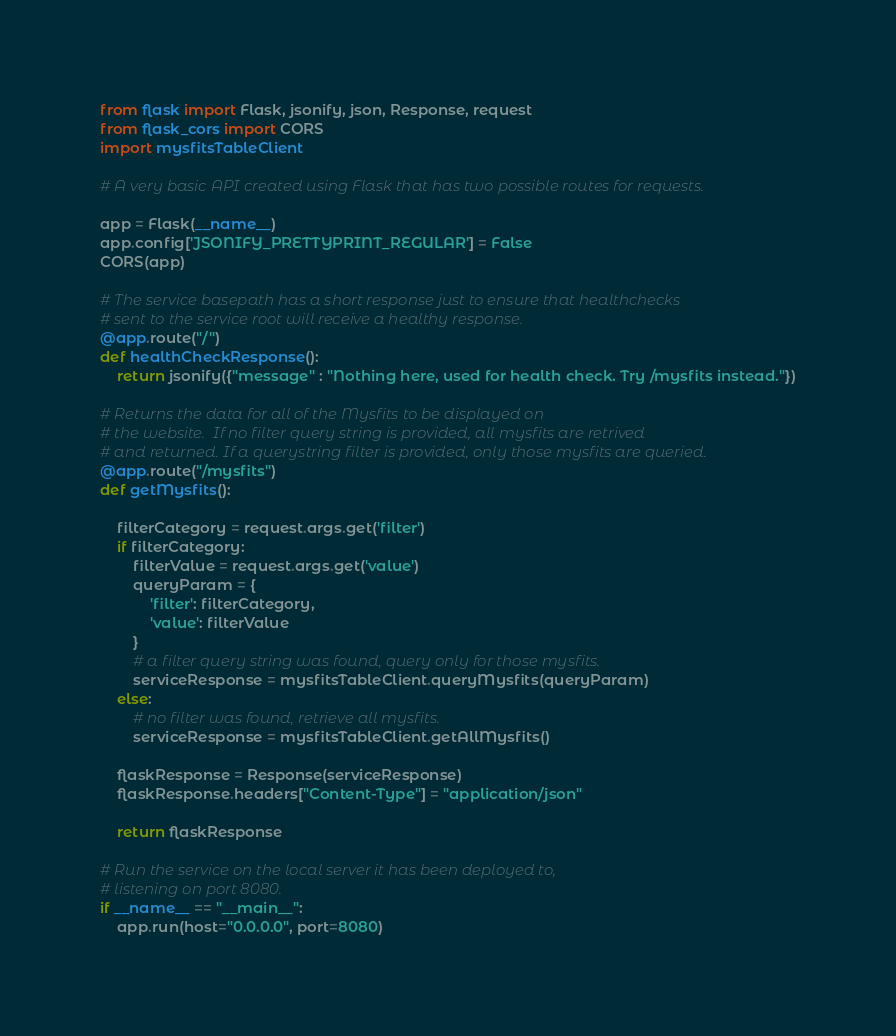Convert code to text. <code><loc_0><loc_0><loc_500><loc_500><_Python_>from flask import Flask, jsonify, json, Response, request
from flask_cors import CORS
import mysfitsTableClient

# A very basic API created using Flask that has two possible routes for requests.

app = Flask(__name__)
app.config['JSONIFY_PRETTYPRINT_REGULAR'] = False
CORS(app)

# The service basepath has a short response just to ensure that healthchecks
# sent to the service root will receive a healthy response.
@app.route("/")
def healthCheckResponse():
    return jsonify({"message" : "Nothing here, used for health check. Try /mysfits instead."})

# Returns the data for all of the Mysfits to be displayed on
# the website.  If no filter query string is provided, all mysfits are retrived
# and returned. If a querystring filter is provided, only those mysfits are queried.
@app.route("/mysfits")
def getMysfits():

    filterCategory = request.args.get('filter')
    if filterCategory:
        filterValue = request.args.get('value')
        queryParam = {
            'filter': filterCategory,
            'value': filterValue
        }
        # a filter query string was found, query only for those mysfits.
        serviceResponse = mysfitsTableClient.queryMysfits(queryParam)
    else:
        # no filter was found, retrieve all mysfits.
        serviceResponse = mysfitsTableClient.getAllMysfits()

    flaskResponse = Response(serviceResponse)
    flaskResponse.headers["Content-Type"] = "application/json"

    return flaskResponse

# Run the service on the local server it has been deployed to,
# listening on port 8080.
if __name__ == "__main__":
    app.run(host="0.0.0.0", port=8080)
</code> 